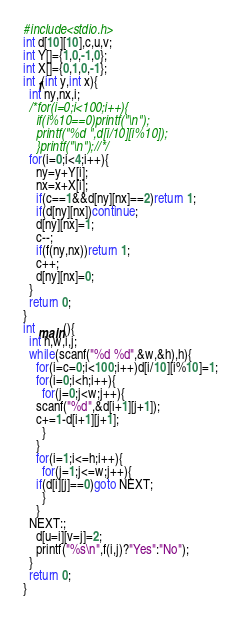Convert code to text. <code><loc_0><loc_0><loc_500><loc_500><_C_>#include<stdio.h>
int d[10][10],c,u,v;
int Y[]={1,0,-1,0};
int X[]={0,1,0,-1};
int f(int y,int x){
  int ny,nx,i;
  /*for(i=0;i<100;i++){
    if(i%10==0)printf("\n");
    printf("%d ",d[i/10][i%10]);
    }printf("\n");//*/
  for(i=0;i<4;i++){
    ny=y+Y[i];
    nx=x+X[i];
    if(c==1&&d[ny][nx]==2)return 1;
    if(d[ny][nx])continue;
    d[ny][nx]=1;
    c--;
    if(f(ny,nx))return 1;
    c++;
    d[ny][nx]=0;
  }
  return 0;
}
int main(){
  int h,w,i,j;
  while(scanf("%d %d",&w,&h),h){
    for(i=c=0;i<100;i++)d[i/10][i%10]=1;
    for(i=0;i<h;i++){
      for(j=0;j<w;j++){
	scanf("%d",&d[i+1][j+1]);
	c+=1-d[i+1][j+1];
      }
    }
    for(i=1;i<=h;i++){
      for(j=1;j<=w;j++){
	if(d[i][j]==0)goto NEXT;
      }
    }
  NEXT:;
    d[u=i][v=j]=2;
    printf("%s\n",f(i,j)?"Yes":"No");
  }
  return 0;
}

</code> 